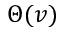Convert formula to latex. <formula><loc_0><loc_0><loc_500><loc_500>\Theta ( v )</formula> 